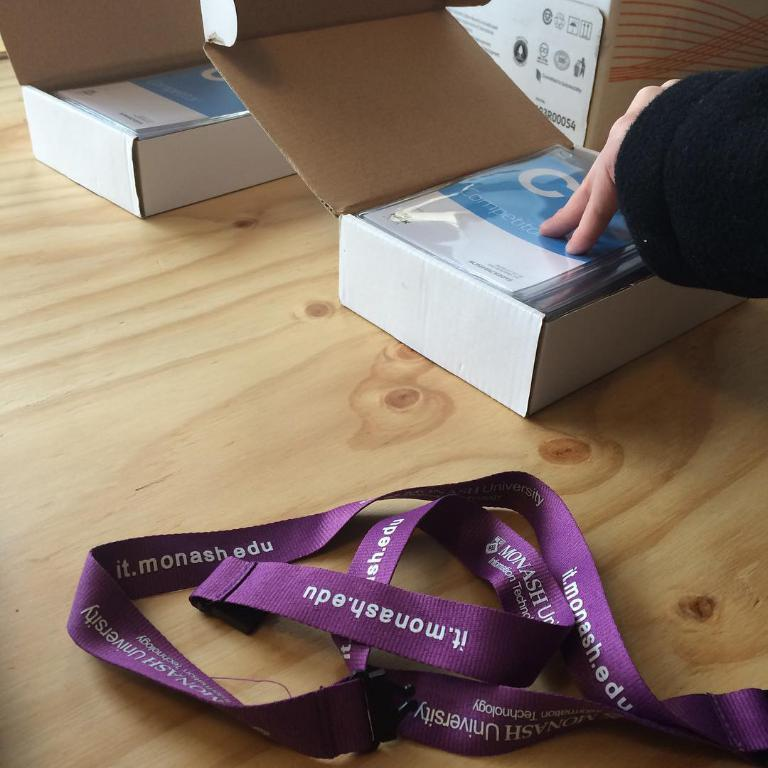What is in the foreground of the image? There is a tag with text on it in the foreground of the image. What is the tag placed on? The tag is on a wooden surface. What can be seen in the background of the image? There are two boxes in the background of the image. Can you describe the describe the interaction with one of the boxes? One of the boxes has a person's hand on it. What type of mountain can be seen in the background of the image? There is no mountain present in the image; it features a tag on a wooden surface and two boxes in the background. 